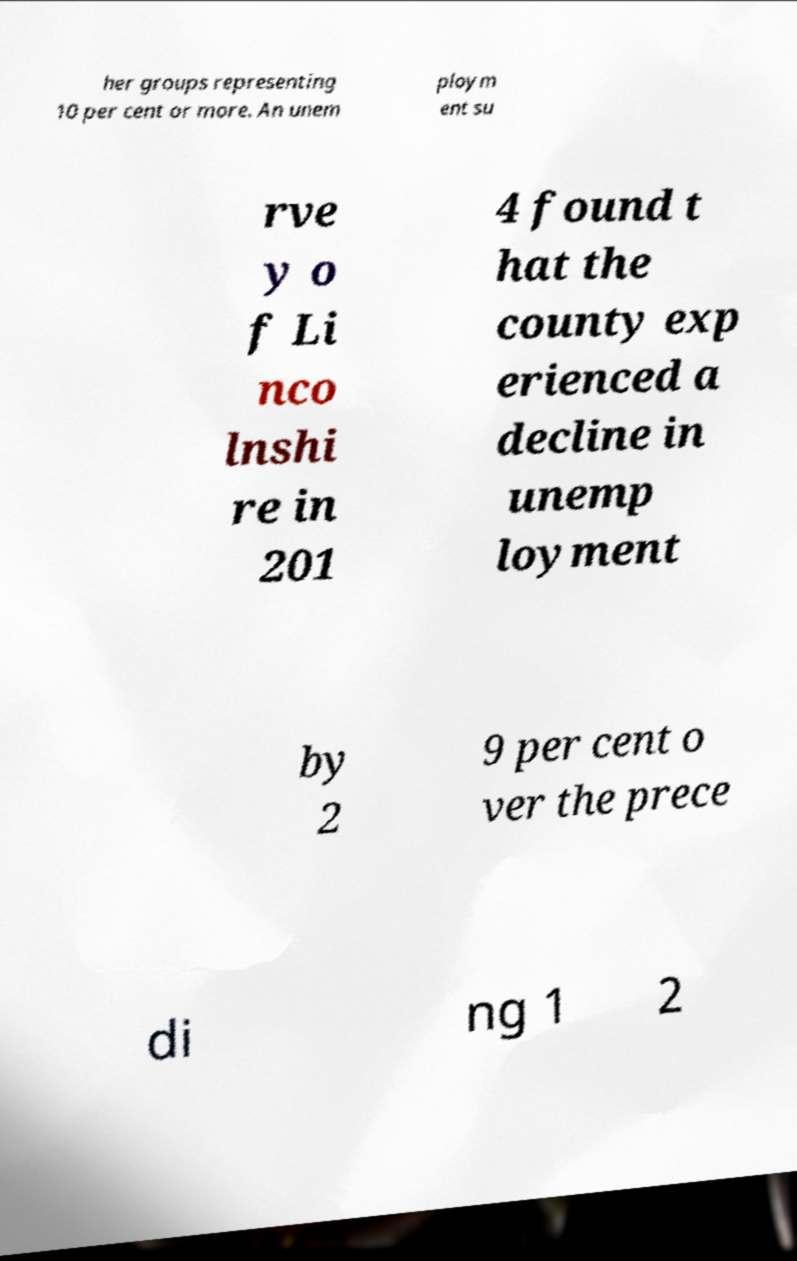I need the written content from this picture converted into text. Can you do that? her groups representing 10 per cent or more. An unem ploym ent su rve y o f Li nco lnshi re in 201 4 found t hat the county exp erienced a decline in unemp loyment by 2 9 per cent o ver the prece di ng 1 2 